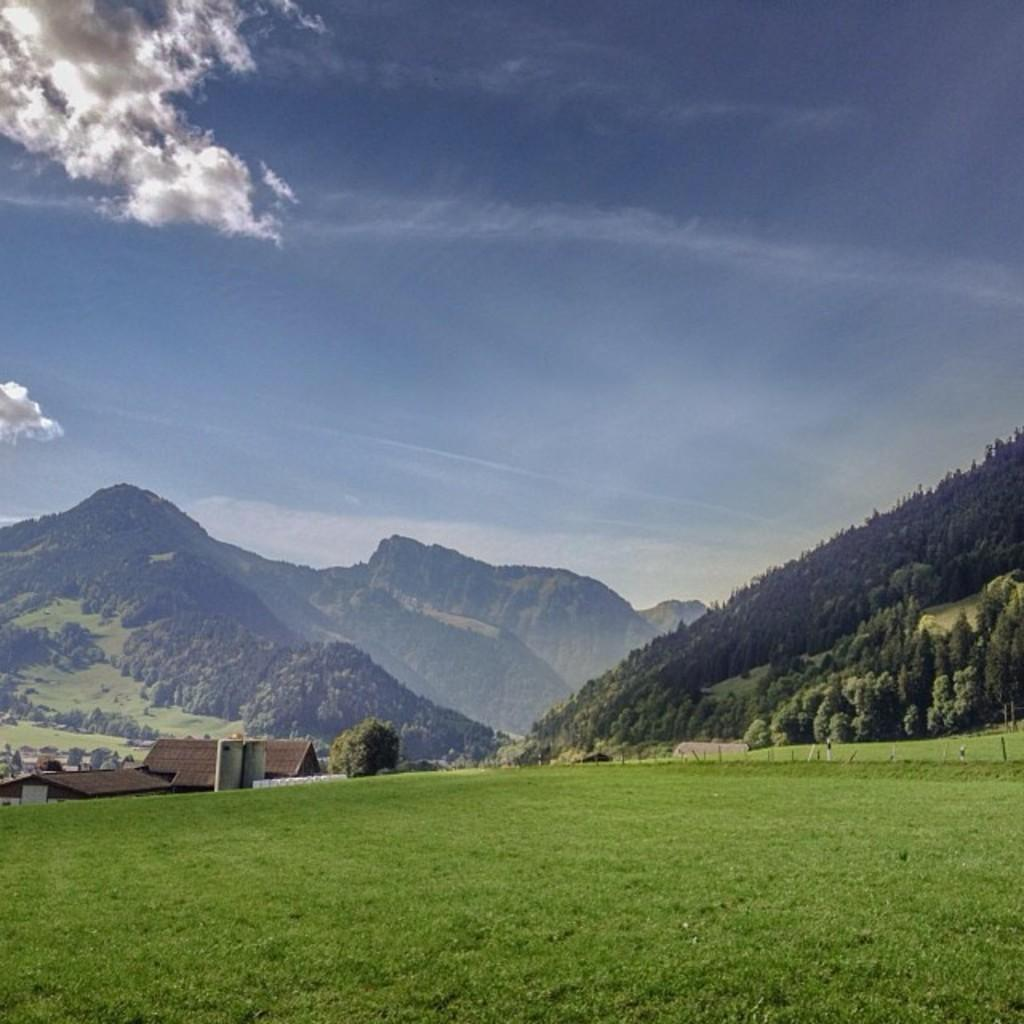What type of natural landscape is depicted in the image? The image features mountains, grass, and trees. What is the weather like in the image? The sky is cloudy in the image. What type of structure can be seen in the image? There is a house in the image. How many cacti are visible in the image? There are no cacti present in the image. What type of branch can be seen extending from the house in the image? There is no branch extending from the house in the image. 